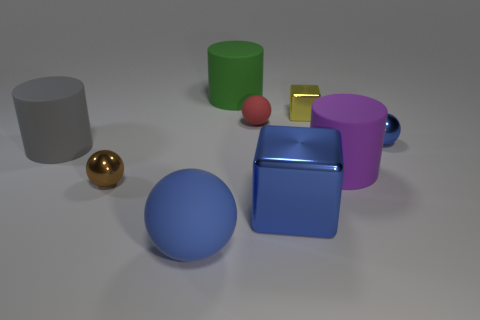There is a big ball that is the same color as the big metallic block; what is its material?
Give a very brief answer. Rubber. There is a yellow metal object; is it the same size as the blue ball that is to the right of the blue shiny cube?
Your answer should be compact. Yes. There is a blue matte object in front of the brown metallic thing; does it have the same size as the tiny yellow metal cube?
Give a very brief answer. No. What number of other objects are there of the same material as the green thing?
Your answer should be compact. 4. Are there an equal number of small yellow shiny blocks behind the small blue shiny ball and red rubber objects behind the small yellow cube?
Offer a terse response. No. There is a metal object that is in front of the small metallic ball that is to the left of the blue matte thing that is in front of the red object; what color is it?
Offer a very short reply. Blue. The large blue thing that is right of the green object has what shape?
Make the answer very short. Cube. There is a big blue thing that is the same material as the big green cylinder; what is its shape?
Your answer should be compact. Sphere. How many blue spheres are on the right side of the small cube?
Ensure brevity in your answer.  1. Are there the same number of balls that are in front of the big purple cylinder and large blue matte cylinders?
Make the answer very short. No. 